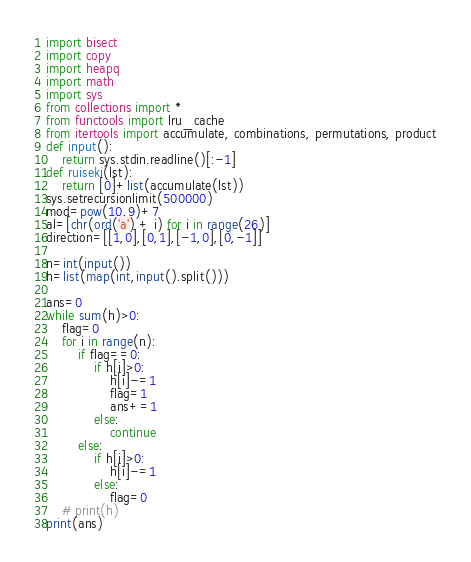<code> <loc_0><loc_0><loc_500><loc_500><_Python_>import bisect
import copy
import heapq
import math
import sys
from collections import *
from functools import lru_cache
from itertools import accumulate, combinations, permutations, product
def input():
    return sys.stdin.readline()[:-1]
def ruiseki(lst):
    return [0]+list(accumulate(lst))
sys.setrecursionlimit(500000)
mod=pow(10,9)+7
al=[chr(ord('a') + i) for i in range(26)]
direction=[[1,0],[0,1],[-1,0],[0,-1]]

n=int(input())
h=list(map(int,input().split()))

ans=0
while sum(h)>0:
    flag=0
    for i in range(n):
        if flag==0:
            if h[i]>0:
                h[i]-=1
                flag=1
                ans+=1
            else:
                continue
        else:
            if h[i]>0:
                h[i]-=1
            else:
                flag=0
    # print(h)
print(ans)</code> 